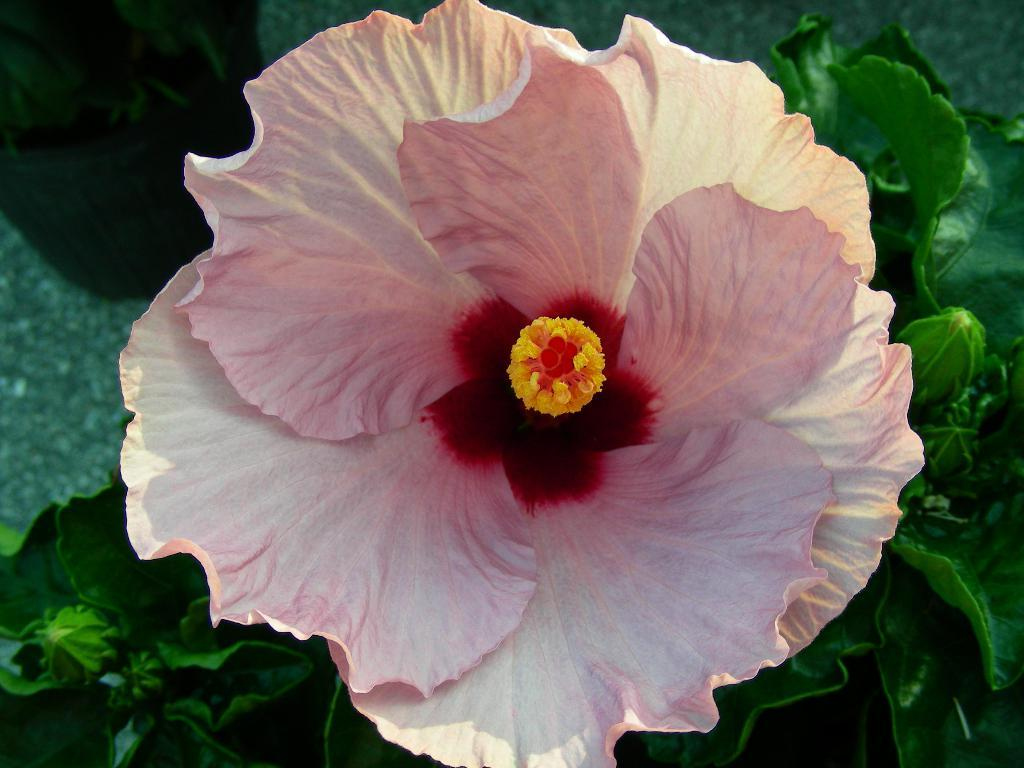What type of flower is present in the image? There is a pink flower in the image. What other plant can be seen in the image? There is a green plant in the image. What type of game is being played in the image? There is no game present in the image; it features a pink flower and a green plant. Can you see any deer in the image? There are no deer present in the image. 